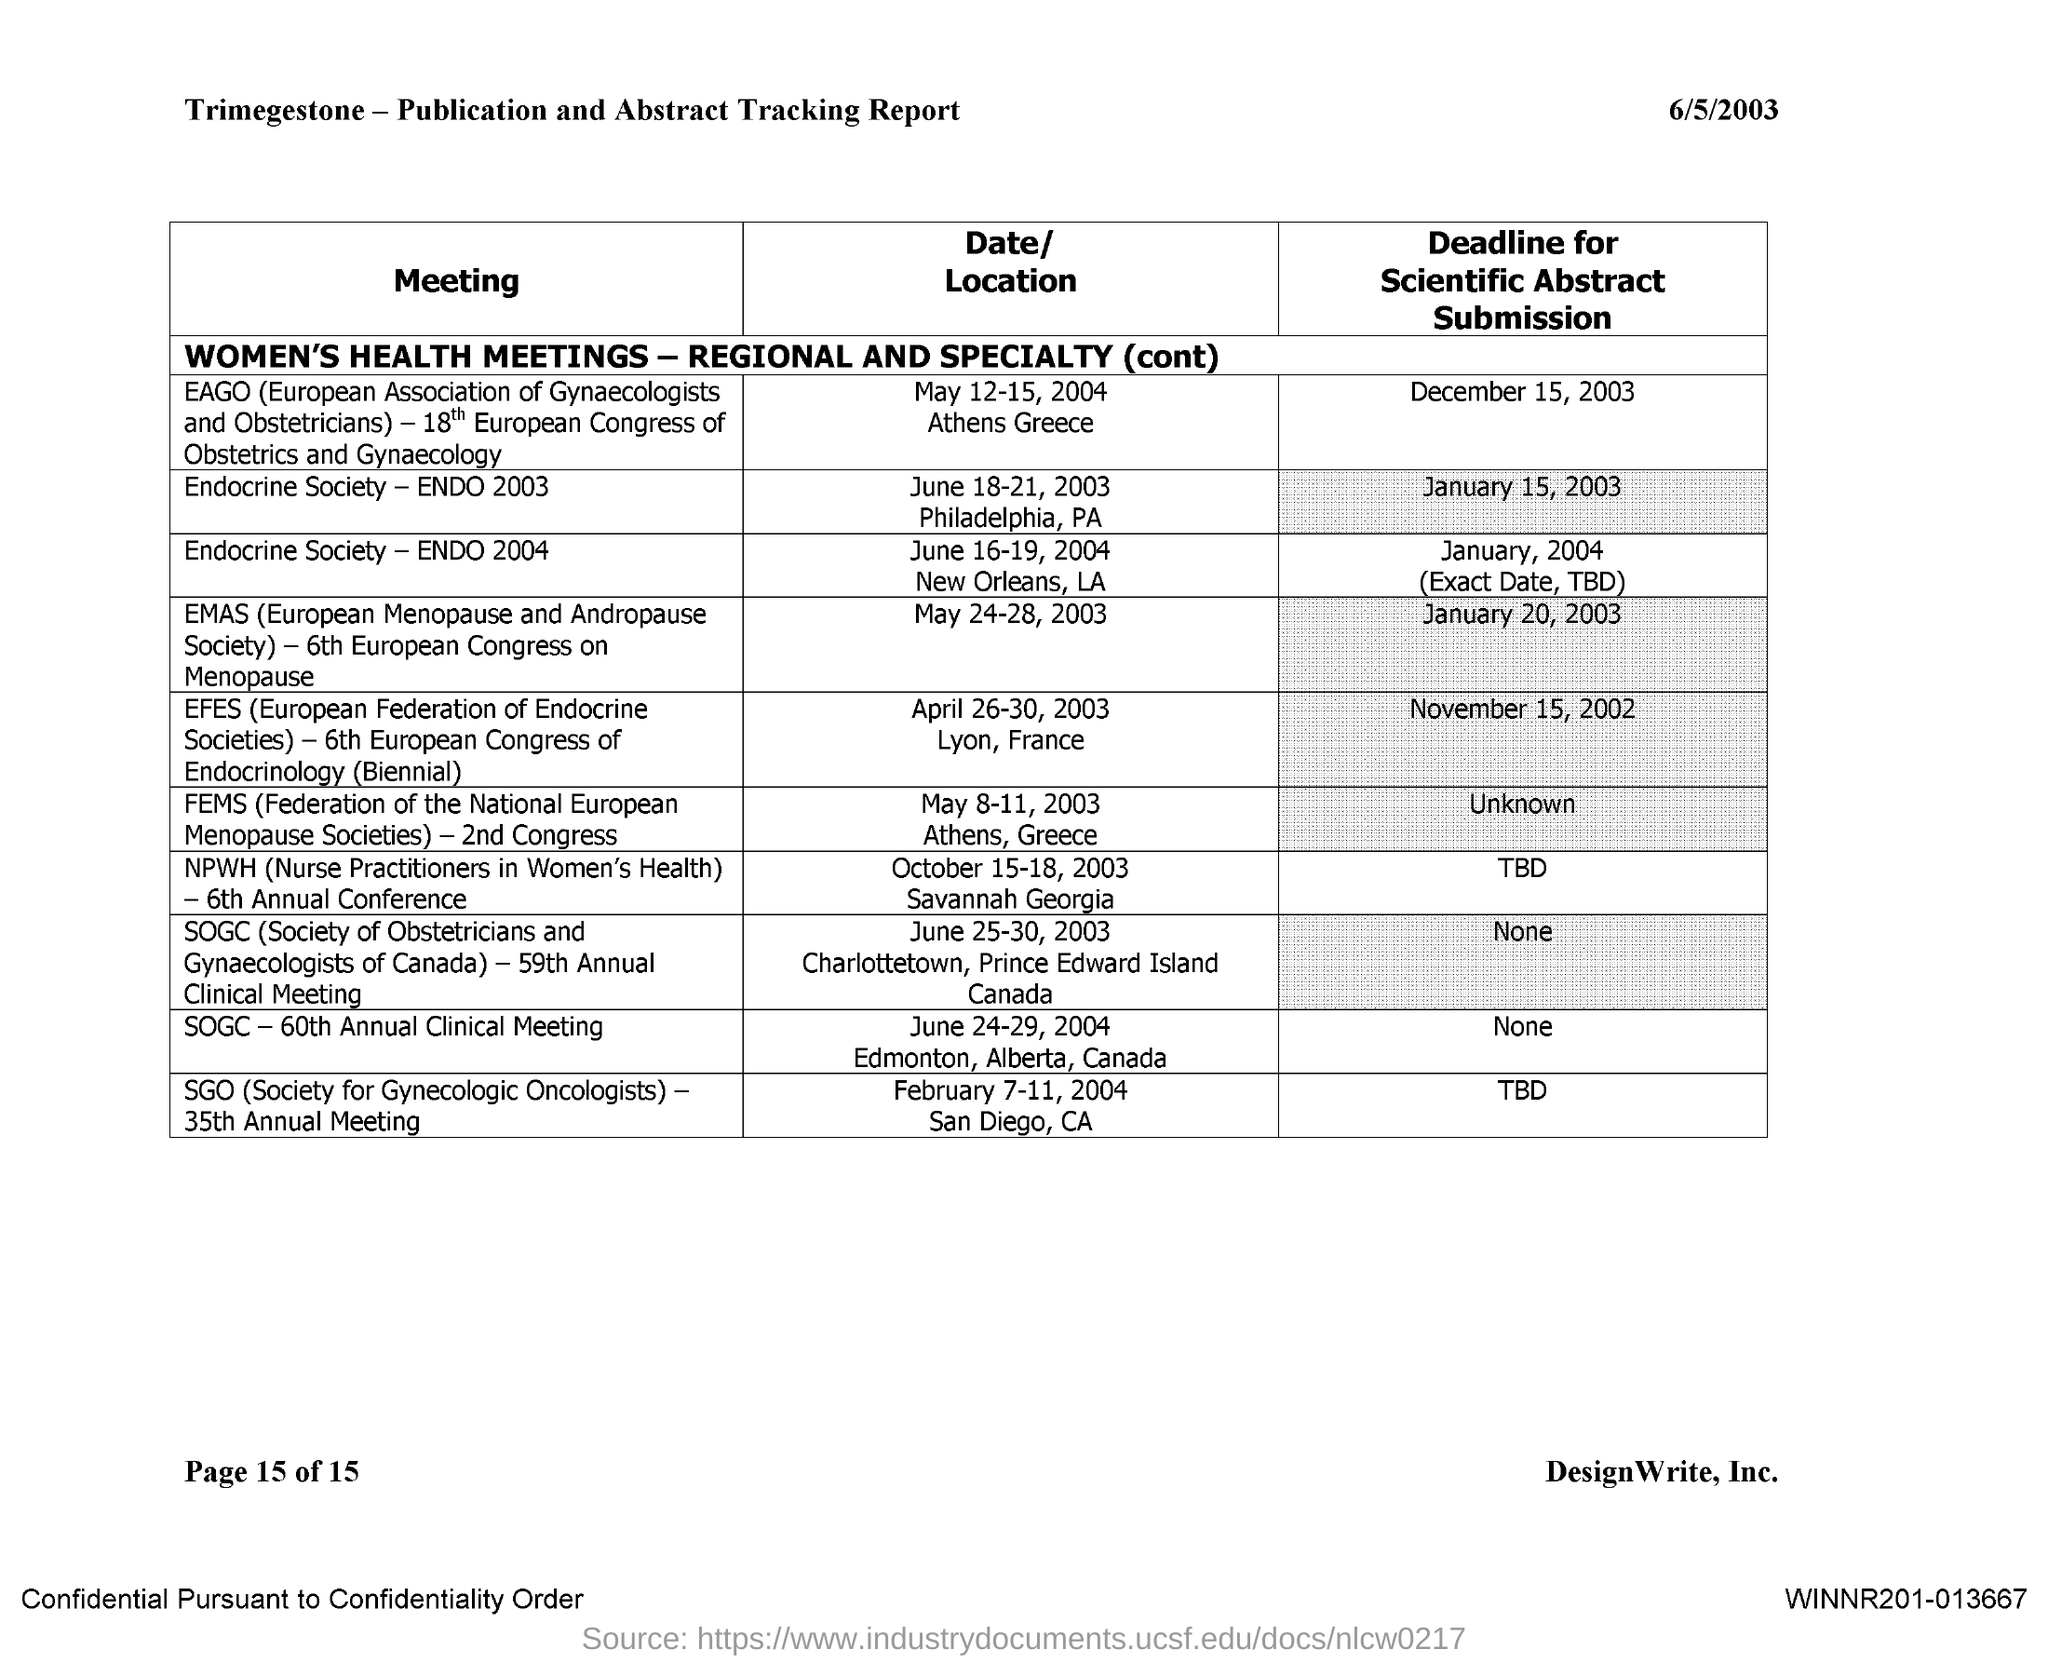What is the date mentioned on the report?
Your answer should be compact. 6/5/2003. What is the heading for first column?
Offer a terse response. Meeting. What is the deadline for scientific abstract submission of endocrine society-2003?
Your answer should be compact. JANUARY 15, 2003. What is the date and location for the SGO 35th annual meeting?
Provide a short and direct response. February 7-11, 2004 San Diego, CA. 